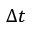<formula> <loc_0><loc_0><loc_500><loc_500>\Delta t</formula> 